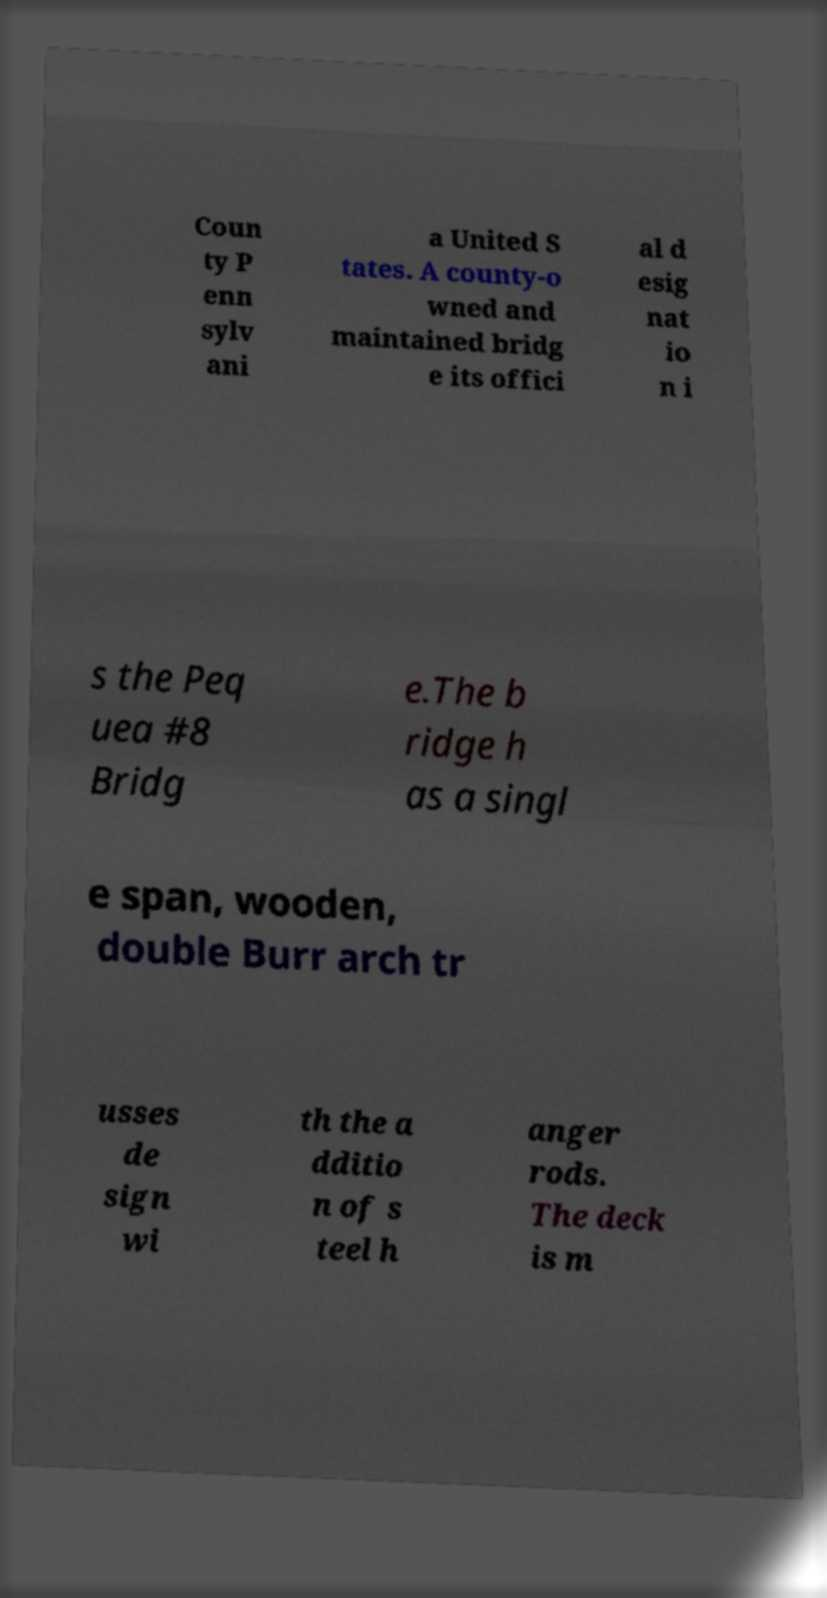Could you extract and type out the text from this image? Coun ty P enn sylv ani a United S tates. A county-o wned and maintained bridg e its offici al d esig nat io n i s the Peq uea #8 Bridg e.The b ridge h as a singl e span, wooden, double Burr arch tr usses de sign wi th the a dditio n of s teel h anger rods. The deck is m 